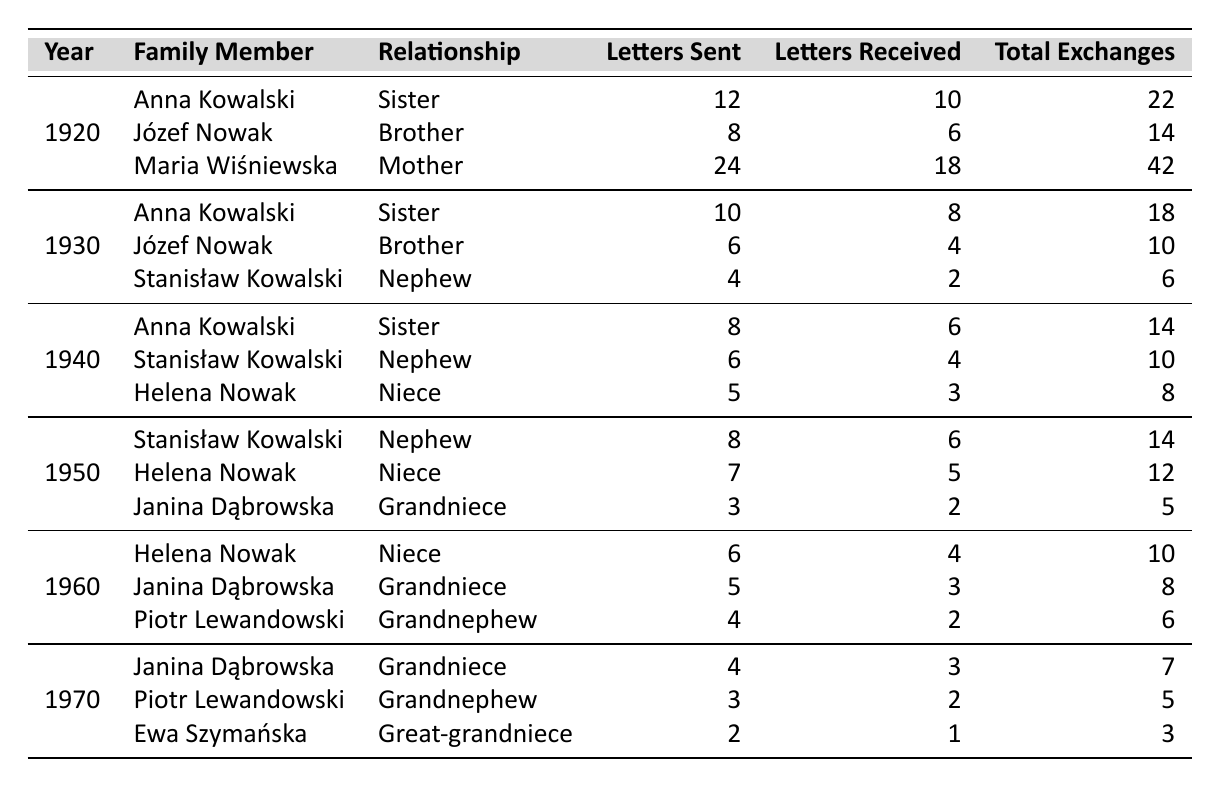What is the total number of letters sent to Anna Kowalski over the decades? In the table, we look for all entries where the family member is Anna Kowalski. She is listed for the years 1920, 1930, and 1940, with letters sent as follows: 12 + 10 + 8 = 30.
Answer: 30 What was the highest number of letters sent in a single year? We check the 'Letters Sent' column for each year. The highest individual numbers are 24 (to Maria Wiśniewska in 1920), followed by 12 (to Anna Kowalski in 1920), and other numbers are lower. Therefore, the highest is 24.
Answer: 24 Did any family member receive more letters than they sent in 1950? In 1950, Helena Nowak received 5 letters and sent 7, Janina Dąbrowska received 2 letters and sent 3, while Stanisław Kowalski sent and received the same amount (6 letters). So, no family member received more than they sent.
Answer: No Which year had the least total letter exchanges? To find the year with the least total exchanges, we sum the 'Total Exchanges' for each year: 22 (1920) + 14 (1920) + 42 (1920) = 78 for 1920; then for 1930: 18 + 10 + 6 = 34; for 1940: 14 + 10 + 8 = 32; for 1950: 14 + 12 + 5 = 31; for 1960: 10 + 8 + 6 = 24; and finally for 1970: 7 + 5 + 3 = 15. Therefore, 1970 has the least total exchanges.
Answer: 1970 What is the average number of letters sent annually to all family members from 1920 to 1970? We sum the letters sent across all years: 12 + 8 + 24 + 10 + 6 + 4 + 8 + 6 + 5 + 8 + 7 + 3 + 6 + 5 + 4 + 4 + 3 + 2 = 115 letters. There are 6 distinct years (1920, 1930, 1940, 1950, 1960, 1970) so we divide 115 by 6. The average is about 19.17 when rounded.
Answer: 19.17 How many total exchanges were made in 1940? We check the 'Total Exchanges' for the year 1940. The sums are 14 (to Anna Kowalski) + 10 (to Stanisław Kowalski) + 8 (to Helena Nowak) = 32.
Answer: 32 Who had the most frequent communication (highest total exchanges) in 1920? We look for the family member with the highest 'Total Exchanges' in 1920. The totals are: Anna Kowalski (22), Józef Nowak (14), and Maria Wiśniewska (42). Maria Wiśniewska had the highest total of 42.
Answer: Maria Wiśniewska What was the trend in letter exchanges from 1920 to 1970? We examine the total exchanges year by year: 1920 (78), 1930 (34), 1940 (32), 1950 (31), 1960 (24), and 1970 (15). The trend shows a decrease in total exchanges over time.
Answer: Decreasing 